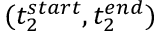<formula> <loc_0><loc_0><loc_500><loc_500>( t _ { 2 } ^ { s t a r t } , t _ { 2 } ^ { e n d } )</formula> 